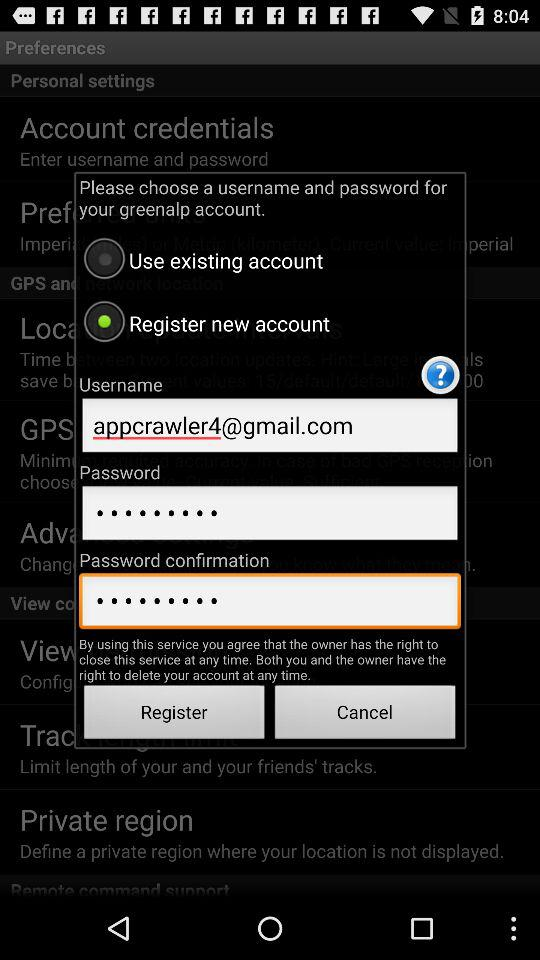What is the email address? The email address is appcrawler4@gmail.com. 